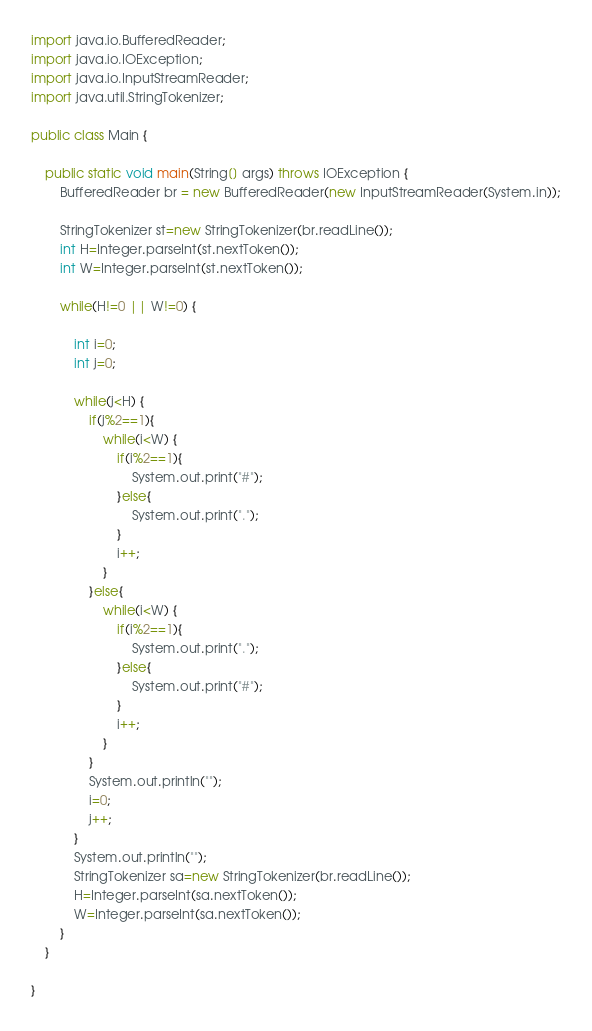Convert code to text. <code><loc_0><loc_0><loc_500><loc_500><_Java_>import java.io.BufferedReader;
import java.io.IOException;
import java.io.InputStreamReader;
import java.util.StringTokenizer;

public class Main {

	public static void main(String[] args) throws IOException {
		BufferedReader br = new BufferedReader(new InputStreamReader(System.in));

        StringTokenizer st=new StringTokenizer(br.readLine());
        int H=Integer.parseInt(st.nextToken());
        int W=Integer.parseInt(st.nextToken());

        while(H!=0 || W!=0) {

            int i=0;
            int j=0;

            while(j<H) {
                if(j%2==1){
                	while(i<W) {
                        if(i%2==1){
                        	System.out.print("#");
                        }else{
                        	System.out.print(".");
                        }
                        i++;
                    }
                }else{
                	while(i<W) {
                        if(i%2==1){
                        	System.out.print(".");
                        }else{
                        	System.out.print("#");
                        }
                        i++;
                    }
                }
                System.out.println("");
                i=0;
                j++;
            }
            System.out.println("");
            StringTokenizer sa=new StringTokenizer(br.readLine());
            H=Integer.parseInt(sa.nextToken());
            W=Integer.parseInt(sa.nextToken());
        }
	}

}

</code> 